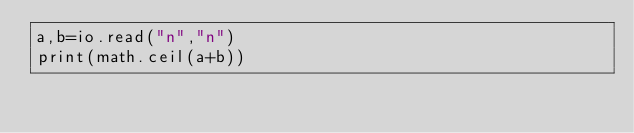<code> <loc_0><loc_0><loc_500><loc_500><_Lua_>a,b=io.read("n","n")
print(math.ceil(a+b))</code> 